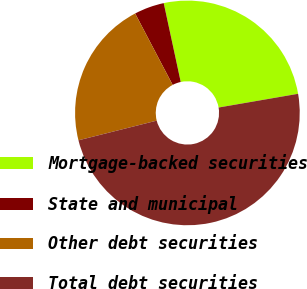Convert chart. <chart><loc_0><loc_0><loc_500><loc_500><pie_chart><fcel>Mortgage-backed securities<fcel>State and municipal<fcel>Other debt securities<fcel>Total debt securities<nl><fcel>25.66%<fcel>4.32%<fcel>21.22%<fcel>48.8%<nl></chart> 